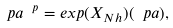<formula> <loc_0><loc_0><loc_500><loc_500>\ p a ^ { \ p } = e x p ( X _ { N h } ) ( \ p a ) ,</formula> 